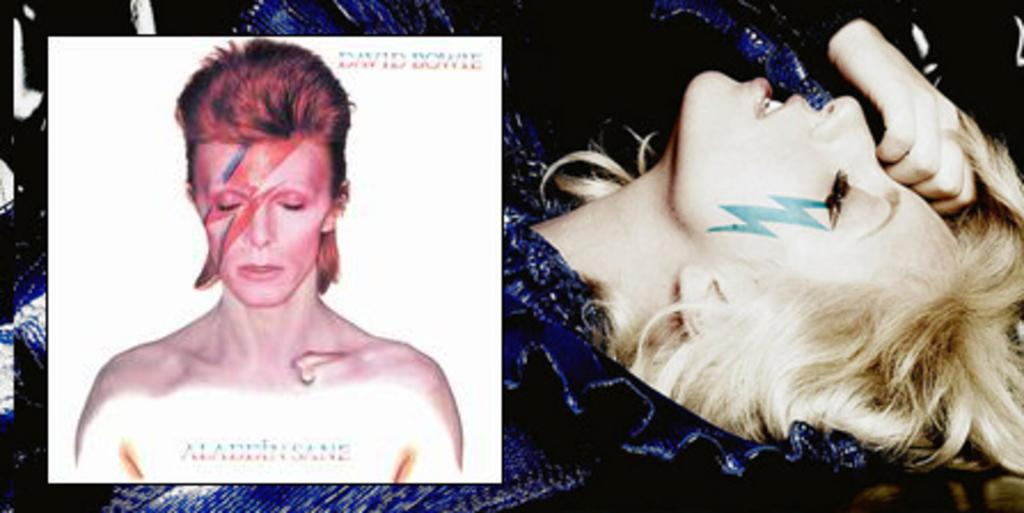What is the main subject of the image? There is a person in the image. Is there any text or writing present in the image? Yes, there is text or writing on the image. Can you describe the background of the image? In the background, there is another person wearing a blue dress. What type of vase is being used for division in the image? There is no vase or division present in the image. What kind of machine is visible in the background of the image? There is no machine visible in the image; only a person wearing a blue dress is present in the background. 